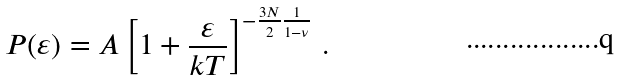Convert formula to latex. <formula><loc_0><loc_0><loc_500><loc_500>P ( \varepsilon ) = A \left [ 1 + \frac { \varepsilon } { k T } \right ] ^ { - \frac { 3 N } { 2 } \frac { 1 } { 1 - \nu } } \, .</formula> 